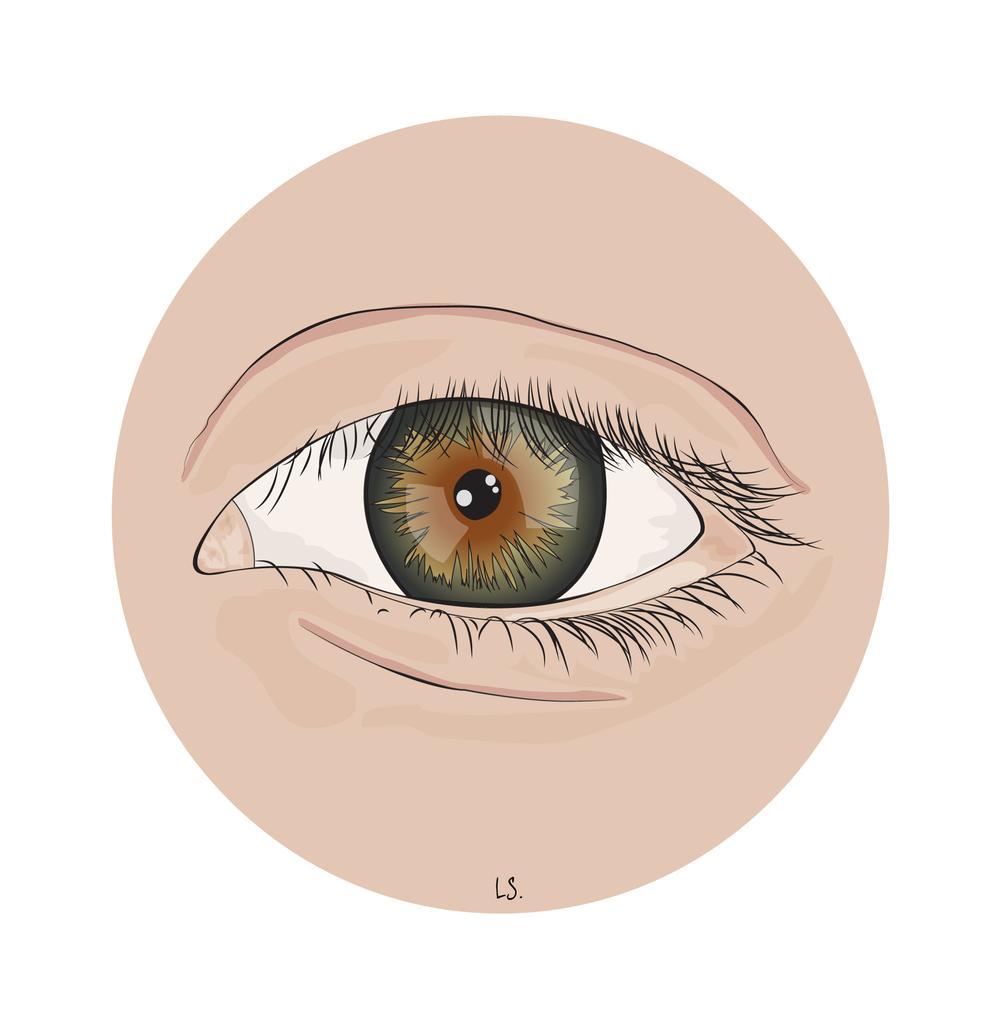Could you give a brief overview of what you see in this image? In this image I can see the digital art of a person's eye which is cream, white, black and brown in color and I can see the white colored background. 